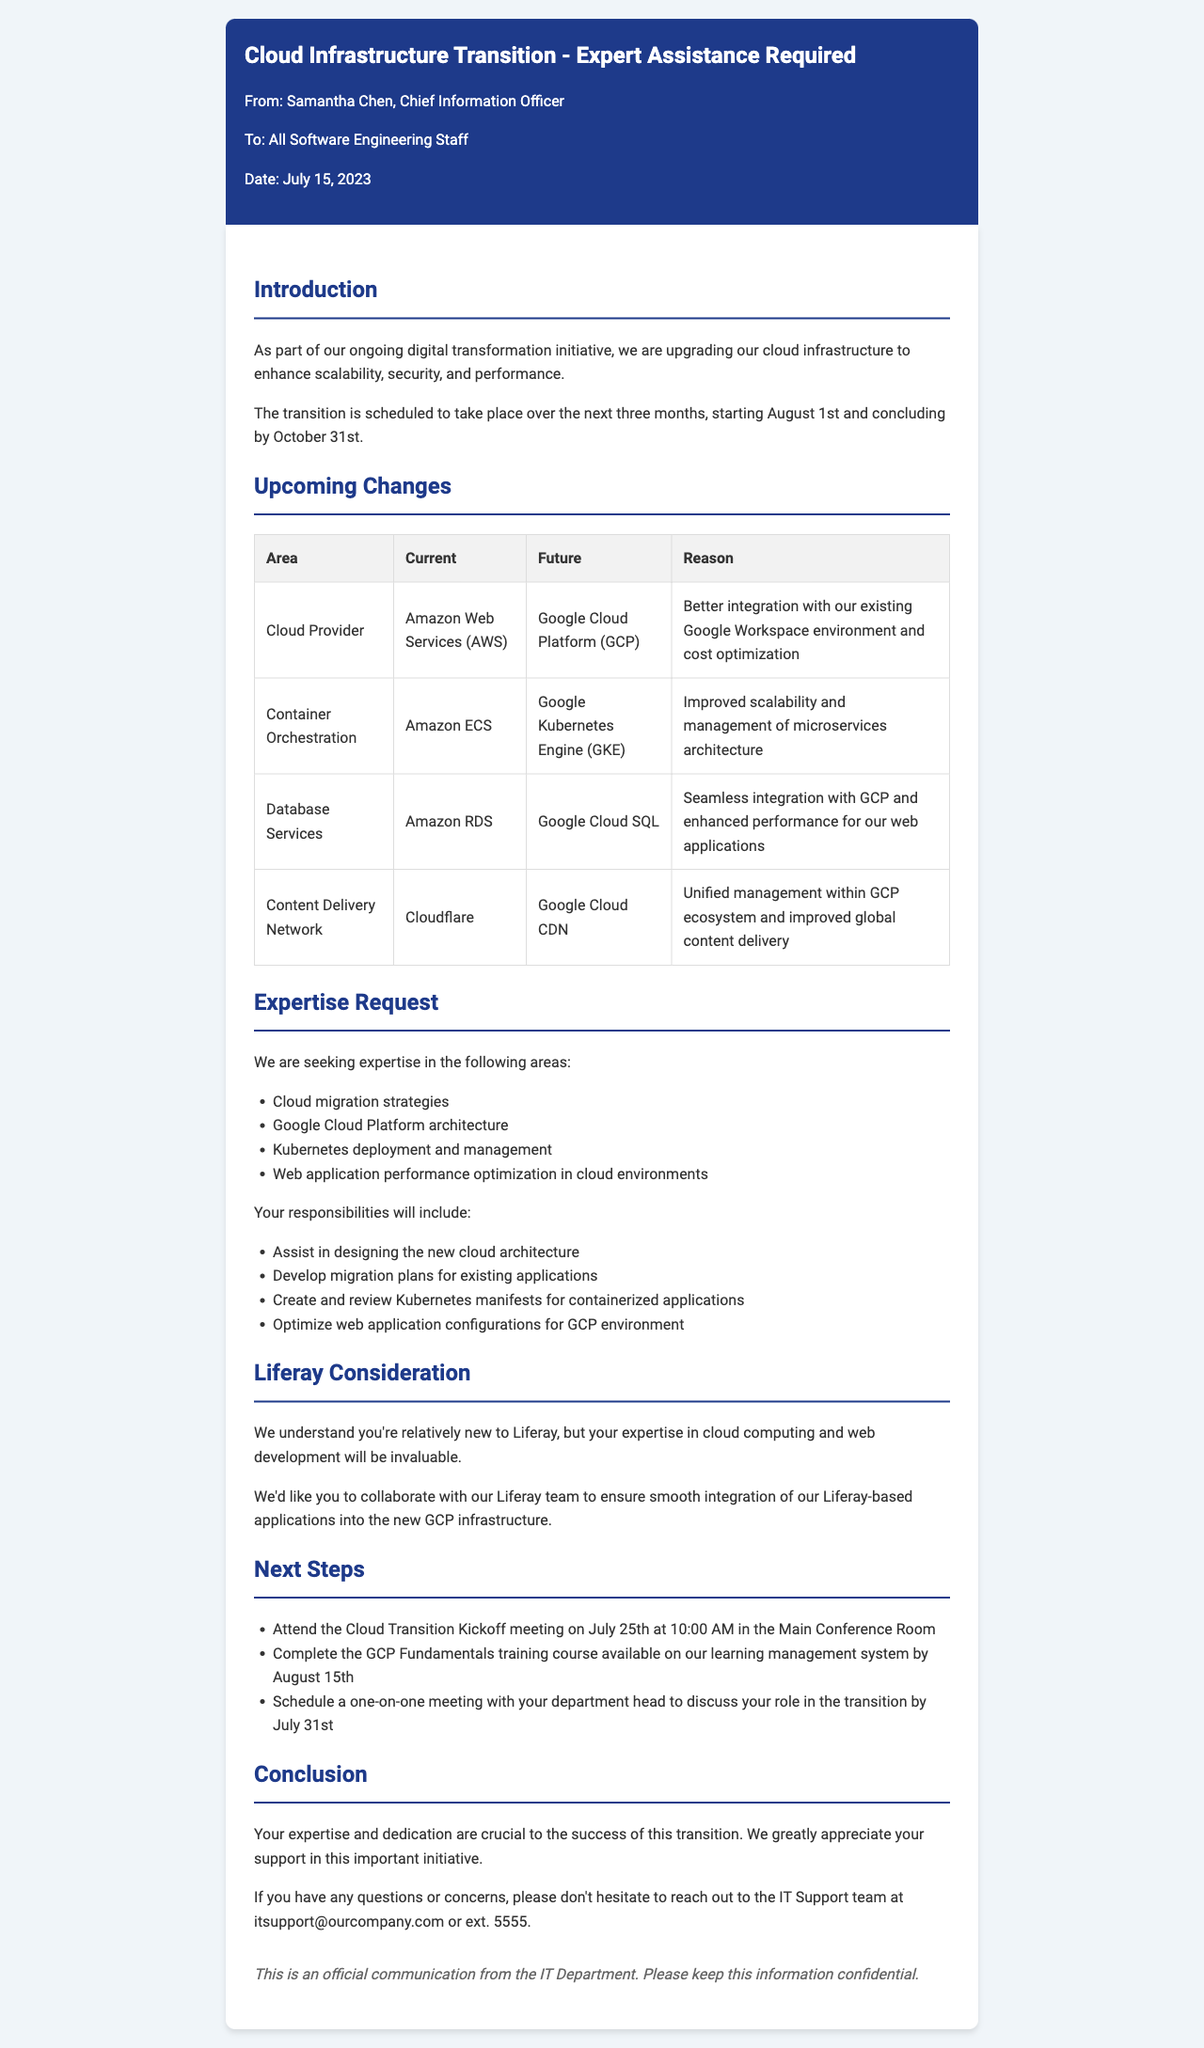What is the subject of the letter? The subject line lists the topic of the letter sent by the IT department to the software engineering staff.
Answer: Cloud Infrastructure Transition - Expert Assistance Required Who is the letter addressed to? The letter specifies the recipients in the "To" section, addressing all software engineering staff.
Answer: All Software Engineering Staff What is the current cloud provider? The letter indicates the current cloud provider being utilized by the company.
Answer: Amazon Web Services (AWS) What is the deadline for completing the GCP Fundamentals training course? The letter outlines a deadline for completing an assigned training course as part of the transition process.
Answer: August 15th What is the reason for switching to Google Kubernetes Engine? The letter explains the benefits of moving to GKE over the current solution, emphasizing performance and scalability.
Answer: Improved scalability and management of microservices architecture What will your responsibilities include? The letter details specific tasks that you will be expected to accomplish during the transition.
Answer: Assist in designing the new cloud architecture When is the Cloud Transition Kickoff meeting? The letter provides a specific date and time for the meeting to discuss the transition.
Answer: July 25th at 10:00 AM What skills are required for this project? The letter lists essential skills that are sought for assistance during the transition to GCP.
Answer: Cloud migration strategies What is the timeframe for the transition process? The letter defines the period within which the transition to the new cloud infrastructure will occur.
Answer: Over the next three months, starting August 1st and concluding by October 31st 